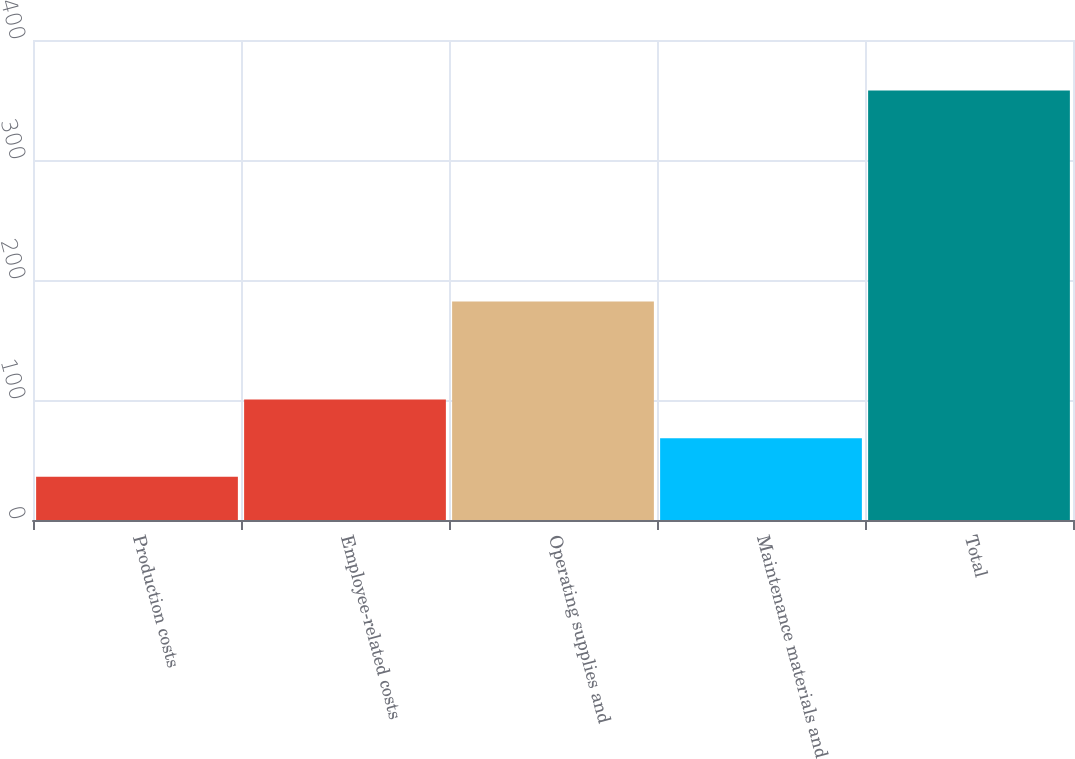Convert chart to OTSL. <chart><loc_0><loc_0><loc_500><loc_500><bar_chart><fcel>Production costs<fcel>Employee-related costs<fcel>Operating supplies and<fcel>Maintenance materials and<fcel>Total<nl><fcel>36<fcel>100.4<fcel>182<fcel>68.2<fcel>358<nl></chart> 